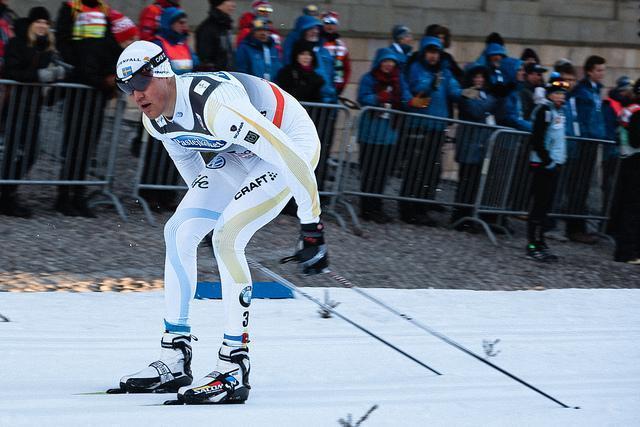How many people are there?
Give a very brief answer. 12. How many horses are shown?
Give a very brief answer. 0. 